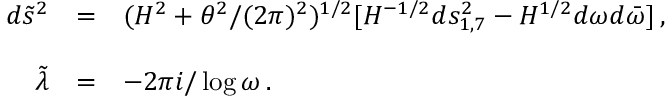<formula> <loc_0><loc_0><loc_500><loc_500>\begin{array} { r c l } { { d { \tilde { s } } ^ { 2 } } } & { = } & { { ( H ^ { 2 } + \theta ^ { 2 } / ( 2 \pi ) ^ { 2 } ) ^ { 1 / 2 } [ H ^ { - 1 / 2 } d s _ { 1 , 7 } ^ { 2 } - H ^ { 1 / 2 } d \omega d { \bar { \omega } } ] \, , } } \\ { { { \tilde { \lambda } } } } & { = } & { { - 2 \pi i / \log { \omega } \, . } } \end{array}</formula> 